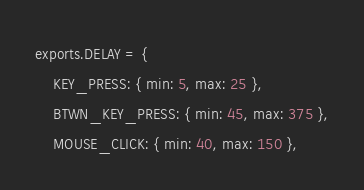<code> <loc_0><loc_0><loc_500><loc_500><_JavaScript_>exports.DELAY = {
    KEY_PRESS: { min: 5, max: 25 },
    BTWN_KEY_PRESS: { min: 45, max: 375 },
    MOUSE_CLICK: { min: 40, max: 150 },</code> 